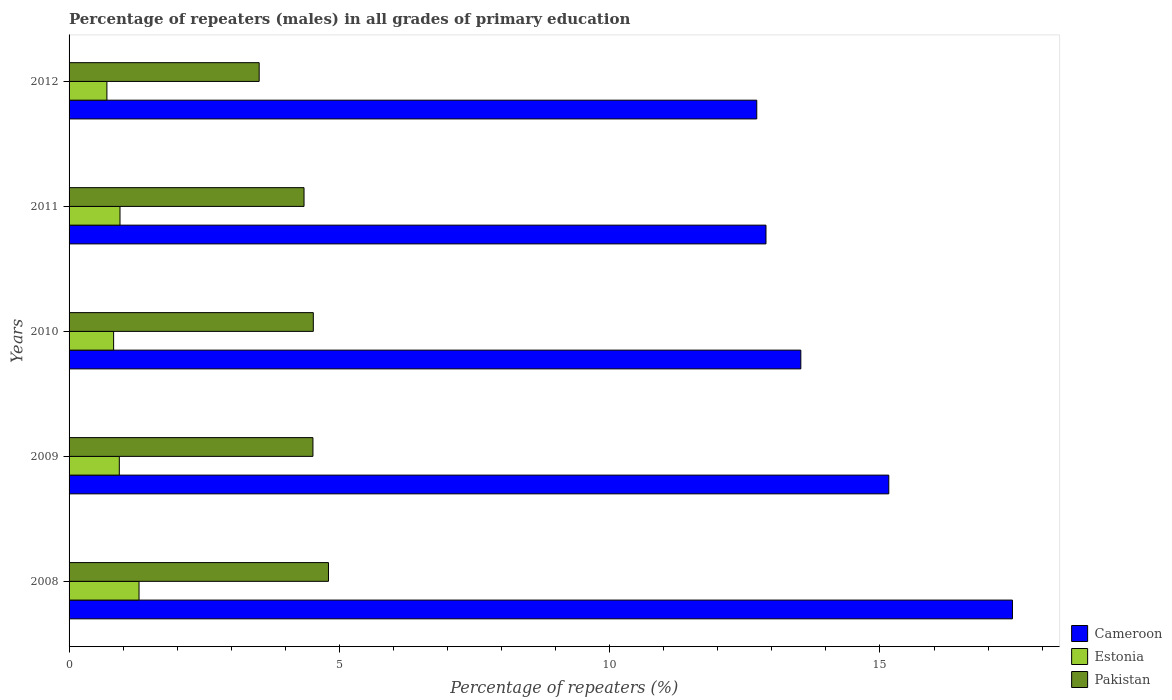Are the number of bars per tick equal to the number of legend labels?
Offer a very short reply. Yes. Are the number of bars on each tick of the Y-axis equal?
Offer a very short reply. Yes. How many bars are there on the 4th tick from the bottom?
Give a very brief answer. 3. What is the percentage of repeaters (males) in Cameroon in 2011?
Offer a terse response. 12.89. Across all years, what is the maximum percentage of repeaters (males) in Pakistan?
Offer a terse response. 4.8. Across all years, what is the minimum percentage of repeaters (males) in Cameroon?
Give a very brief answer. 12.72. In which year was the percentage of repeaters (males) in Cameroon maximum?
Make the answer very short. 2008. What is the total percentage of repeaters (males) in Pakistan in the graph?
Keep it short and to the point. 21.69. What is the difference between the percentage of repeaters (males) in Pakistan in 2008 and that in 2012?
Your answer should be compact. 1.28. What is the difference between the percentage of repeaters (males) in Estonia in 2011 and the percentage of repeaters (males) in Cameroon in 2012?
Give a very brief answer. -11.78. What is the average percentage of repeaters (males) in Estonia per year?
Your response must be concise. 0.94. In the year 2011, what is the difference between the percentage of repeaters (males) in Cameroon and percentage of repeaters (males) in Pakistan?
Provide a succinct answer. 8.55. What is the ratio of the percentage of repeaters (males) in Cameroon in 2010 to that in 2011?
Keep it short and to the point. 1.05. Is the percentage of repeaters (males) in Estonia in 2008 less than that in 2011?
Give a very brief answer. No. What is the difference between the highest and the second highest percentage of repeaters (males) in Pakistan?
Offer a very short reply. 0.28. What is the difference between the highest and the lowest percentage of repeaters (males) in Pakistan?
Offer a very short reply. 1.28. What does the 1st bar from the top in 2011 represents?
Your answer should be compact. Pakistan. What does the 1st bar from the bottom in 2010 represents?
Make the answer very short. Cameroon. Is it the case that in every year, the sum of the percentage of repeaters (males) in Pakistan and percentage of repeaters (males) in Cameroon is greater than the percentage of repeaters (males) in Estonia?
Offer a very short reply. Yes. How many years are there in the graph?
Ensure brevity in your answer.  5. How many legend labels are there?
Provide a short and direct response. 3. How are the legend labels stacked?
Provide a succinct answer. Vertical. What is the title of the graph?
Offer a terse response. Percentage of repeaters (males) in all grades of primary education. What is the label or title of the X-axis?
Your response must be concise. Percentage of repeaters (%). What is the Percentage of repeaters (%) in Cameroon in 2008?
Provide a succinct answer. 17.45. What is the Percentage of repeaters (%) in Estonia in 2008?
Offer a very short reply. 1.29. What is the Percentage of repeaters (%) in Pakistan in 2008?
Make the answer very short. 4.8. What is the Percentage of repeaters (%) of Cameroon in 2009?
Your answer should be very brief. 15.16. What is the Percentage of repeaters (%) of Estonia in 2009?
Keep it short and to the point. 0.93. What is the Percentage of repeaters (%) of Pakistan in 2009?
Keep it short and to the point. 4.51. What is the Percentage of repeaters (%) of Cameroon in 2010?
Your answer should be compact. 13.54. What is the Percentage of repeaters (%) in Estonia in 2010?
Ensure brevity in your answer.  0.82. What is the Percentage of repeaters (%) in Pakistan in 2010?
Keep it short and to the point. 4.52. What is the Percentage of repeaters (%) of Cameroon in 2011?
Your response must be concise. 12.89. What is the Percentage of repeaters (%) in Estonia in 2011?
Keep it short and to the point. 0.94. What is the Percentage of repeaters (%) of Pakistan in 2011?
Keep it short and to the point. 4.35. What is the Percentage of repeaters (%) in Cameroon in 2012?
Give a very brief answer. 12.72. What is the Percentage of repeaters (%) in Estonia in 2012?
Your answer should be very brief. 0.7. What is the Percentage of repeaters (%) of Pakistan in 2012?
Provide a succinct answer. 3.52. Across all years, what is the maximum Percentage of repeaters (%) of Cameroon?
Provide a short and direct response. 17.45. Across all years, what is the maximum Percentage of repeaters (%) of Estonia?
Offer a terse response. 1.29. Across all years, what is the maximum Percentage of repeaters (%) in Pakistan?
Keep it short and to the point. 4.8. Across all years, what is the minimum Percentage of repeaters (%) in Cameroon?
Ensure brevity in your answer.  12.72. Across all years, what is the minimum Percentage of repeaters (%) of Estonia?
Offer a very short reply. 0.7. Across all years, what is the minimum Percentage of repeaters (%) of Pakistan?
Your answer should be very brief. 3.52. What is the total Percentage of repeaters (%) in Cameroon in the graph?
Offer a very short reply. 71.76. What is the total Percentage of repeaters (%) in Estonia in the graph?
Offer a very short reply. 4.69. What is the total Percentage of repeaters (%) of Pakistan in the graph?
Give a very brief answer. 21.69. What is the difference between the Percentage of repeaters (%) in Cameroon in 2008 and that in 2009?
Your answer should be very brief. 2.29. What is the difference between the Percentage of repeaters (%) of Estonia in 2008 and that in 2009?
Provide a short and direct response. 0.36. What is the difference between the Percentage of repeaters (%) in Pakistan in 2008 and that in 2009?
Provide a short and direct response. 0.29. What is the difference between the Percentage of repeaters (%) of Cameroon in 2008 and that in 2010?
Your answer should be very brief. 3.91. What is the difference between the Percentage of repeaters (%) in Estonia in 2008 and that in 2010?
Keep it short and to the point. 0.47. What is the difference between the Percentage of repeaters (%) of Pakistan in 2008 and that in 2010?
Your response must be concise. 0.28. What is the difference between the Percentage of repeaters (%) of Cameroon in 2008 and that in 2011?
Keep it short and to the point. 4.56. What is the difference between the Percentage of repeaters (%) in Estonia in 2008 and that in 2011?
Provide a short and direct response. 0.35. What is the difference between the Percentage of repeaters (%) of Pakistan in 2008 and that in 2011?
Ensure brevity in your answer.  0.45. What is the difference between the Percentage of repeaters (%) of Cameroon in 2008 and that in 2012?
Your answer should be compact. 4.73. What is the difference between the Percentage of repeaters (%) in Estonia in 2008 and that in 2012?
Provide a succinct answer. 0.59. What is the difference between the Percentage of repeaters (%) of Pakistan in 2008 and that in 2012?
Your answer should be very brief. 1.28. What is the difference between the Percentage of repeaters (%) of Cameroon in 2009 and that in 2010?
Your answer should be compact. 1.63. What is the difference between the Percentage of repeaters (%) of Estonia in 2009 and that in 2010?
Ensure brevity in your answer.  0.11. What is the difference between the Percentage of repeaters (%) of Pakistan in 2009 and that in 2010?
Make the answer very short. -0.01. What is the difference between the Percentage of repeaters (%) in Cameroon in 2009 and that in 2011?
Offer a terse response. 2.27. What is the difference between the Percentage of repeaters (%) in Estonia in 2009 and that in 2011?
Your answer should be very brief. -0.01. What is the difference between the Percentage of repeaters (%) in Pakistan in 2009 and that in 2011?
Offer a terse response. 0.16. What is the difference between the Percentage of repeaters (%) in Cameroon in 2009 and that in 2012?
Offer a very short reply. 2.44. What is the difference between the Percentage of repeaters (%) in Estonia in 2009 and that in 2012?
Your answer should be compact. 0.23. What is the difference between the Percentage of repeaters (%) in Cameroon in 2010 and that in 2011?
Keep it short and to the point. 0.64. What is the difference between the Percentage of repeaters (%) in Estonia in 2010 and that in 2011?
Your response must be concise. -0.12. What is the difference between the Percentage of repeaters (%) in Pakistan in 2010 and that in 2011?
Provide a short and direct response. 0.17. What is the difference between the Percentage of repeaters (%) in Cameroon in 2010 and that in 2012?
Your answer should be very brief. 0.81. What is the difference between the Percentage of repeaters (%) in Estonia in 2010 and that in 2012?
Offer a terse response. 0.12. What is the difference between the Percentage of repeaters (%) of Pakistan in 2010 and that in 2012?
Ensure brevity in your answer.  1. What is the difference between the Percentage of repeaters (%) of Cameroon in 2011 and that in 2012?
Offer a very short reply. 0.17. What is the difference between the Percentage of repeaters (%) in Estonia in 2011 and that in 2012?
Offer a very short reply. 0.24. What is the difference between the Percentage of repeaters (%) of Pakistan in 2011 and that in 2012?
Offer a terse response. 0.83. What is the difference between the Percentage of repeaters (%) of Cameroon in 2008 and the Percentage of repeaters (%) of Estonia in 2009?
Give a very brief answer. 16.52. What is the difference between the Percentage of repeaters (%) in Cameroon in 2008 and the Percentage of repeaters (%) in Pakistan in 2009?
Provide a succinct answer. 12.94. What is the difference between the Percentage of repeaters (%) in Estonia in 2008 and the Percentage of repeaters (%) in Pakistan in 2009?
Your answer should be very brief. -3.22. What is the difference between the Percentage of repeaters (%) of Cameroon in 2008 and the Percentage of repeaters (%) of Estonia in 2010?
Provide a succinct answer. 16.63. What is the difference between the Percentage of repeaters (%) of Cameroon in 2008 and the Percentage of repeaters (%) of Pakistan in 2010?
Offer a terse response. 12.93. What is the difference between the Percentage of repeaters (%) in Estonia in 2008 and the Percentage of repeaters (%) in Pakistan in 2010?
Provide a succinct answer. -3.22. What is the difference between the Percentage of repeaters (%) in Cameroon in 2008 and the Percentage of repeaters (%) in Estonia in 2011?
Ensure brevity in your answer.  16.51. What is the difference between the Percentage of repeaters (%) in Cameroon in 2008 and the Percentage of repeaters (%) in Pakistan in 2011?
Provide a succinct answer. 13.1. What is the difference between the Percentage of repeaters (%) in Estonia in 2008 and the Percentage of repeaters (%) in Pakistan in 2011?
Your response must be concise. -3.05. What is the difference between the Percentage of repeaters (%) in Cameroon in 2008 and the Percentage of repeaters (%) in Estonia in 2012?
Your answer should be very brief. 16.75. What is the difference between the Percentage of repeaters (%) in Cameroon in 2008 and the Percentage of repeaters (%) in Pakistan in 2012?
Provide a short and direct response. 13.93. What is the difference between the Percentage of repeaters (%) in Estonia in 2008 and the Percentage of repeaters (%) in Pakistan in 2012?
Keep it short and to the point. -2.22. What is the difference between the Percentage of repeaters (%) in Cameroon in 2009 and the Percentage of repeaters (%) in Estonia in 2010?
Offer a very short reply. 14.34. What is the difference between the Percentage of repeaters (%) of Cameroon in 2009 and the Percentage of repeaters (%) of Pakistan in 2010?
Your response must be concise. 10.65. What is the difference between the Percentage of repeaters (%) of Estonia in 2009 and the Percentage of repeaters (%) of Pakistan in 2010?
Your answer should be compact. -3.59. What is the difference between the Percentage of repeaters (%) in Cameroon in 2009 and the Percentage of repeaters (%) in Estonia in 2011?
Ensure brevity in your answer.  14.22. What is the difference between the Percentage of repeaters (%) of Cameroon in 2009 and the Percentage of repeaters (%) of Pakistan in 2011?
Provide a short and direct response. 10.82. What is the difference between the Percentage of repeaters (%) in Estonia in 2009 and the Percentage of repeaters (%) in Pakistan in 2011?
Keep it short and to the point. -3.42. What is the difference between the Percentage of repeaters (%) of Cameroon in 2009 and the Percentage of repeaters (%) of Estonia in 2012?
Ensure brevity in your answer.  14.46. What is the difference between the Percentage of repeaters (%) of Cameroon in 2009 and the Percentage of repeaters (%) of Pakistan in 2012?
Provide a succinct answer. 11.65. What is the difference between the Percentage of repeaters (%) of Estonia in 2009 and the Percentage of repeaters (%) of Pakistan in 2012?
Provide a short and direct response. -2.59. What is the difference between the Percentage of repeaters (%) in Cameroon in 2010 and the Percentage of repeaters (%) in Estonia in 2011?
Ensure brevity in your answer.  12.59. What is the difference between the Percentage of repeaters (%) of Cameroon in 2010 and the Percentage of repeaters (%) of Pakistan in 2011?
Your answer should be compact. 9.19. What is the difference between the Percentage of repeaters (%) of Estonia in 2010 and the Percentage of repeaters (%) of Pakistan in 2011?
Offer a terse response. -3.52. What is the difference between the Percentage of repeaters (%) of Cameroon in 2010 and the Percentage of repeaters (%) of Estonia in 2012?
Your response must be concise. 12.84. What is the difference between the Percentage of repeaters (%) of Cameroon in 2010 and the Percentage of repeaters (%) of Pakistan in 2012?
Provide a short and direct response. 10.02. What is the difference between the Percentage of repeaters (%) in Estonia in 2010 and the Percentage of repeaters (%) in Pakistan in 2012?
Provide a succinct answer. -2.69. What is the difference between the Percentage of repeaters (%) of Cameroon in 2011 and the Percentage of repeaters (%) of Estonia in 2012?
Your answer should be compact. 12.19. What is the difference between the Percentage of repeaters (%) of Cameroon in 2011 and the Percentage of repeaters (%) of Pakistan in 2012?
Give a very brief answer. 9.37. What is the difference between the Percentage of repeaters (%) in Estonia in 2011 and the Percentage of repeaters (%) in Pakistan in 2012?
Give a very brief answer. -2.57. What is the average Percentage of repeaters (%) of Cameroon per year?
Make the answer very short. 14.35. What is the average Percentage of repeaters (%) of Estonia per year?
Your answer should be compact. 0.94. What is the average Percentage of repeaters (%) in Pakistan per year?
Ensure brevity in your answer.  4.34. In the year 2008, what is the difference between the Percentage of repeaters (%) in Cameroon and Percentage of repeaters (%) in Estonia?
Make the answer very short. 16.16. In the year 2008, what is the difference between the Percentage of repeaters (%) in Cameroon and Percentage of repeaters (%) in Pakistan?
Make the answer very short. 12.65. In the year 2008, what is the difference between the Percentage of repeaters (%) of Estonia and Percentage of repeaters (%) of Pakistan?
Make the answer very short. -3.5. In the year 2009, what is the difference between the Percentage of repeaters (%) in Cameroon and Percentage of repeaters (%) in Estonia?
Ensure brevity in your answer.  14.23. In the year 2009, what is the difference between the Percentage of repeaters (%) in Cameroon and Percentage of repeaters (%) in Pakistan?
Make the answer very short. 10.65. In the year 2009, what is the difference between the Percentage of repeaters (%) of Estonia and Percentage of repeaters (%) of Pakistan?
Offer a very short reply. -3.58. In the year 2010, what is the difference between the Percentage of repeaters (%) of Cameroon and Percentage of repeaters (%) of Estonia?
Offer a terse response. 12.71. In the year 2010, what is the difference between the Percentage of repeaters (%) of Cameroon and Percentage of repeaters (%) of Pakistan?
Give a very brief answer. 9.02. In the year 2010, what is the difference between the Percentage of repeaters (%) of Estonia and Percentage of repeaters (%) of Pakistan?
Provide a succinct answer. -3.69. In the year 2011, what is the difference between the Percentage of repeaters (%) in Cameroon and Percentage of repeaters (%) in Estonia?
Offer a terse response. 11.95. In the year 2011, what is the difference between the Percentage of repeaters (%) of Cameroon and Percentage of repeaters (%) of Pakistan?
Make the answer very short. 8.55. In the year 2011, what is the difference between the Percentage of repeaters (%) in Estonia and Percentage of repeaters (%) in Pakistan?
Provide a short and direct response. -3.4. In the year 2012, what is the difference between the Percentage of repeaters (%) of Cameroon and Percentage of repeaters (%) of Estonia?
Make the answer very short. 12.02. In the year 2012, what is the difference between the Percentage of repeaters (%) of Cameroon and Percentage of repeaters (%) of Pakistan?
Keep it short and to the point. 9.2. In the year 2012, what is the difference between the Percentage of repeaters (%) in Estonia and Percentage of repeaters (%) in Pakistan?
Ensure brevity in your answer.  -2.82. What is the ratio of the Percentage of repeaters (%) in Cameroon in 2008 to that in 2009?
Keep it short and to the point. 1.15. What is the ratio of the Percentage of repeaters (%) in Estonia in 2008 to that in 2009?
Your answer should be compact. 1.39. What is the ratio of the Percentage of repeaters (%) in Pakistan in 2008 to that in 2009?
Make the answer very short. 1.06. What is the ratio of the Percentage of repeaters (%) in Cameroon in 2008 to that in 2010?
Give a very brief answer. 1.29. What is the ratio of the Percentage of repeaters (%) of Estonia in 2008 to that in 2010?
Ensure brevity in your answer.  1.57. What is the ratio of the Percentage of repeaters (%) in Pakistan in 2008 to that in 2010?
Your answer should be very brief. 1.06. What is the ratio of the Percentage of repeaters (%) in Cameroon in 2008 to that in 2011?
Keep it short and to the point. 1.35. What is the ratio of the Percentage of repeaters (%) of Estonia in 2008 to that in 2011?
Keep it short and to the point. 1.37. What is the ratio of the Percentage of repeaters (%) of Pakistan in 2008 to that in 2011?
Keep it short and to the point. 1.1. What is the ratio of the Percentage of repeaters (%) of Cameroon in 2008 to that in 2012?
Offer a terse response. 1.37. What is the ratio of the Percentage of repeaters (%) in Estonia in 2008 to that in 2012?
Your answer should be compact. 1.85. What is the ratio of the Percentage of repeaters (%) in Pakistan in 2008 to that in 2012?
Offer a terse response. 1.36. What is the ratio of the Percentage of repeaters (%) of Cameroon in 2009 to that in 2010?
Provide a succinct answer. 1.12. What is the ratio of the Percentage of repeaters (%) in Estonia in 2009 to that in 2010?
Keep it short and to the point. 1.13. What is the ratio of the Percentage of repeaters (%) of Pakistan in 2009 to that in 2010?
Ensure brevity in your answer.  1. What is the ratio of the Percentage of repeaters (%) of Cameroon in 2009 to that in 2011?
Your response must be concise. 1.18. What is the ratio of the Percentage of repeaters (%) of Estonia in 2009 to that in 2011?
Give a very brief answer. 0.99. What is the ratio of the Percentage of repeaters (%) of Pakistan in 2009 to that in 2011?
Your response must be concise. 1.04. What is the ratio of the Percentage of repeaters (%) of Cameroon in 2009 to that in 2012?
Make the answer very short. 1.19. What is the ratio of the Percentage of repeaters (%) of Estonia in 2009 to that in 2012?
Your answer should be compact. 1.33. What is the ratio of the Percentage of repeaters (%) of Pakistan in 2009 to that in 2012?
Provide a succinct answer. 1.28. What is the ratio of the Percentage of repeaters (%) in Cameroon in 2010 to that in 2011?
Your response must be concise. 1.05. What is the ratio of the Percentage of repeaters (%) of Estonia in 2010 to that in 2011?
Offer a terse response. 0.87. What is the ratio of the Percentage of repeaters (%) in Pakistan in 2010 to that in 2011?
Give a very brief answer. 1.04. What is the ratio of the Percentage of repeaters (%) in Cameroon in 2010 to that in 2012?
Provide a short and direct response. 1.06. What is the ratio of the Percentage of repeaters (%) of Estonia in 2010 to that in 2012?
Your answer should be very brief. 1.18. What is the ratio of the Percentage of repeaters (%) of Pakistan in 2010 to that in 2012?
Provide a short and direct response. 1.28. What is the ratio of the Percentage of repeaters (%) in Cameroon in 2011 to that in 2012?
Make the answer very short. 1.01. What is the ratio of the Percentage of repeaters (%) in Estonia in 2011 to that in 2012?
Your answer should be very brief. 1.35. What is the ratio of the Percentage of repeaters (%) in Pakistan in 2011 to that in 2012?
Provide a short and direct response. 1.24. What is the difference between the highest and the second highest Percentage of repeaters (%) of Cameroon?
Provide a short and direct response. 2.29. What is the difference between the highest and the second highest Percentage of repeaters (%) in Estonia?
Give a very brief answer. 0.35. What is the difference between the highest and the second highest Percentage of repeaters (%) of Pakistan?
Offer a terse response. 0.28. What is the difference between the highest and the lowest Percentage of repeaters (%) in Cameroon?
Offer a terse response. 4.73. What is the difference between the highest and the lowest Percentage of repeaters (%) of Estonia?
Provide a succinct answer. 0.59. What is the difference between the highest and the lowest Percentage of repeaters (%) of Pakistan?
Offer a terse response. 1.28. 